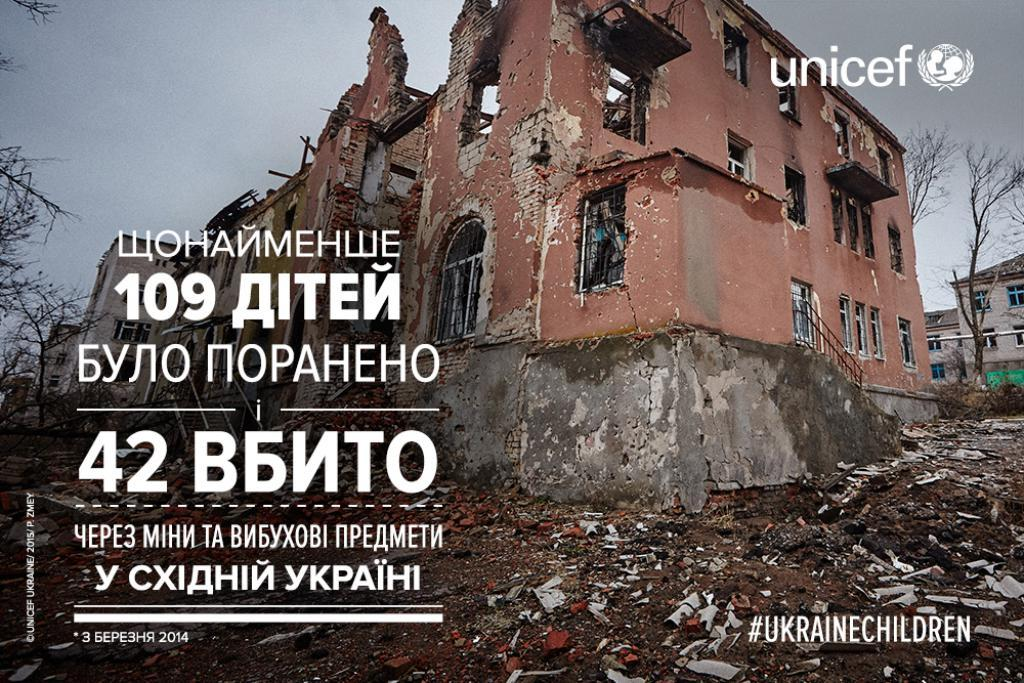What can be found on the picture? There is text on the picture. What is the main subject of the image? There is a destroyed building in the image. What can be seen in the background of the image? There are trees, buildings, and the sky visible in the background of the image. Can you tell me how many verses of the volleyball game are mentioned in the image? There is no mention of a volleyball game or verses in the image; it features text and a destroyed building. What type of glove is being used by the person in the image? There is no person or glove present in the image. 